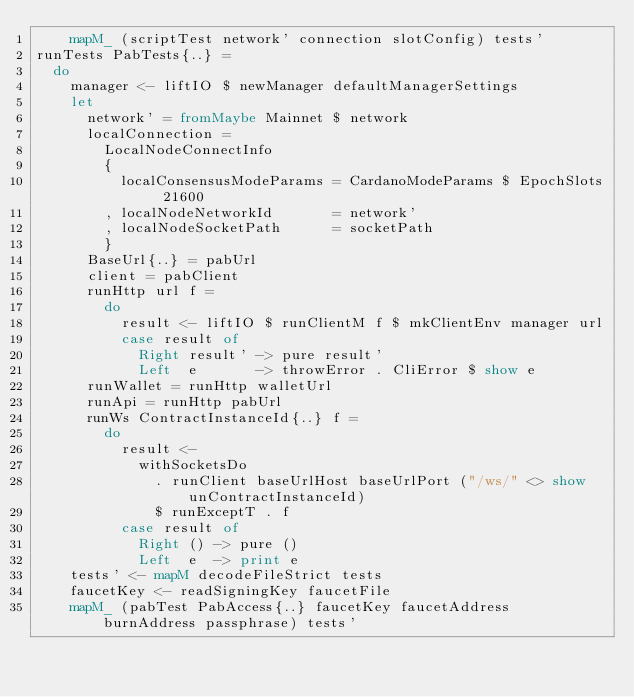<code> <loc_0><loc_0><loc_500><loc_500><_Haskell_>    mapM_ (scriptTest network' connection slotConfig) tests'
runTests PabTests{..} =
  do
    manager <- liftIO $ newManager defaultManagerSettings
    let
      network' = fromMaybe Mainnet $ network
      localConnection =
        LocalNodeConnectInfo
        {
          localConsensusModeParams = CardanoModeParams $ EpochSlots 21600
        , localNodeNetworkId       = network'
        , localNodeSocketPath      = socketPath
        }
      BaseUrl{..} = pabUrl
      client = pabClient
      runHttp url f =
        do
          result <- liftIO $ runClientM f $ mkClientEnv manager url
          case result of
            Right result' -> pure result'
            Left  e       -> throwError . CliError $ show e
      runWallet = runHttp walletUrl
      runApi = runHttp pabUrl
      runWs ContractInstanceId{..} f =
        do
          result <-
            withSocketsDo
              . runClient baseUrlHost baseUrlPort ("/ws/" <> show unContractInstanceId)
              $ runExceptT . f
          case result of
            Right () -> pure ()
            Left  e  -> print e
    tests' <- mapM decodeFileStrict tests
    faucetKey <- readSigningKey faucetFile
    mapM_ (pabTest PabAccess{..} faucetKey faucetAddress burnAddress passphrase) tests'
</code> 